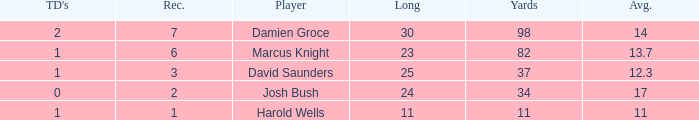How many TDs are there were the long is smaller than 23? 1.0. 